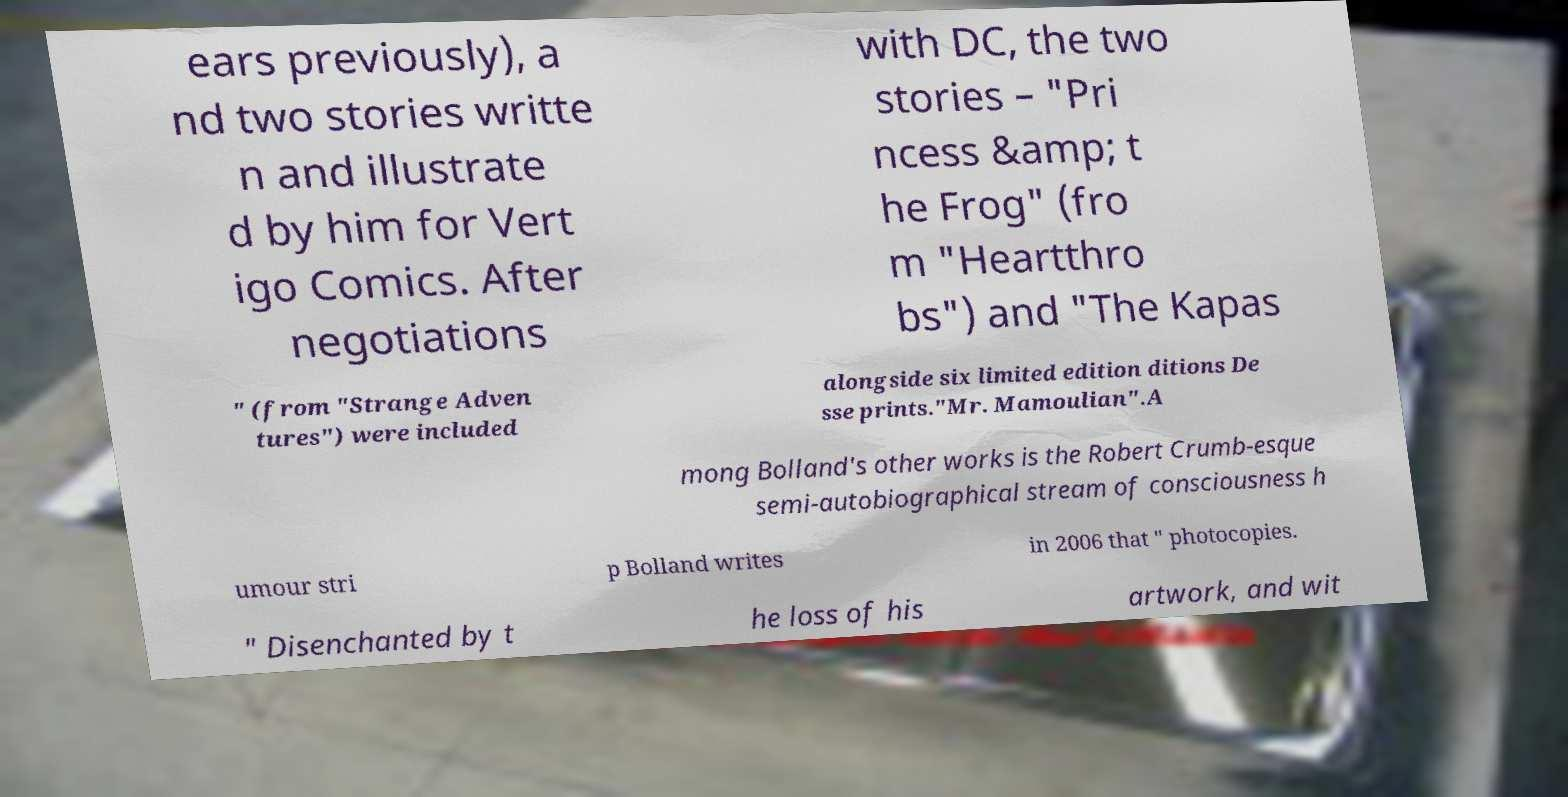There's text embedded in this image that I need extracted. Can you transcribe it verbatim? ears previously), a nd two stories writte n and illustrate d by him for Vert igo Comics. After negotiations with DC, the two stories – "Pri ncess &amp; t he Frog" (fro m "Heartthro bs") and "The Kapas " (from "Strange Adven tures") were included alongside six limited edition ditions De sse prints."Mr. Mamoulian".A mong Bolland's other works is the Robert Crumb-esque semi-autobiographical stream of consciousness h umour stri p Bolland writes in 2006 that " photocopies. " Disenchanted by t he loss of his artwork, and wit 